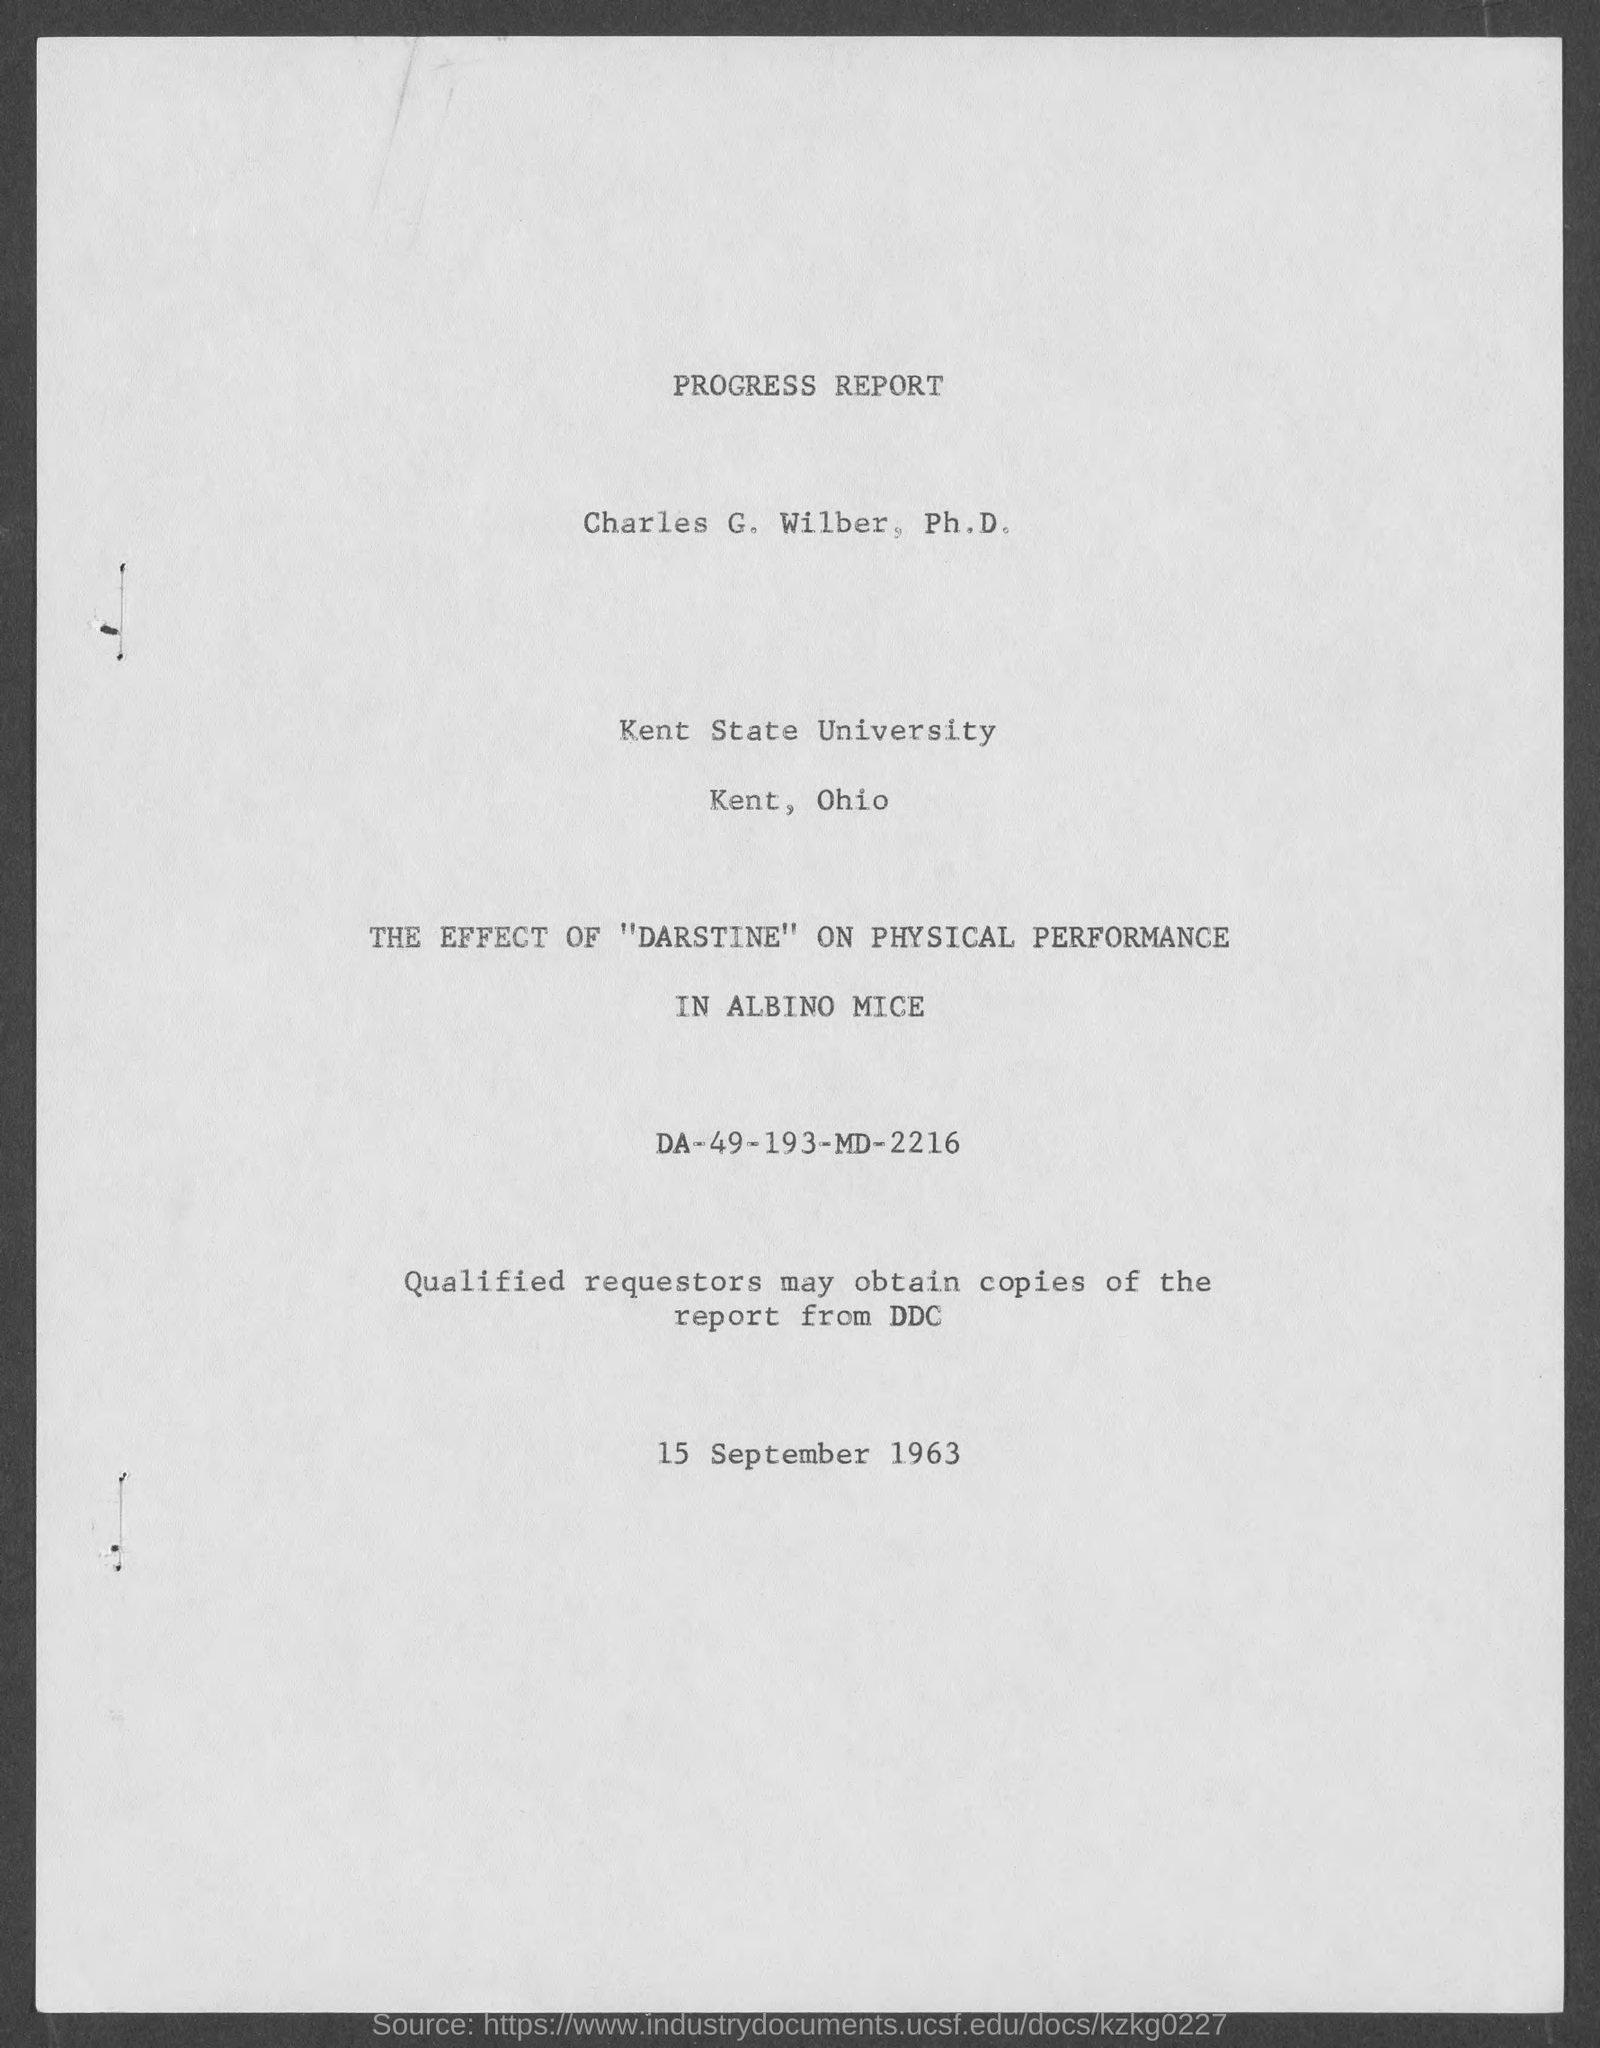What is the date at bottom of the page?
Offer a very short reply. 15 September 1963. In which state is kent state university located ?
Make the answer very short. Ohio. 